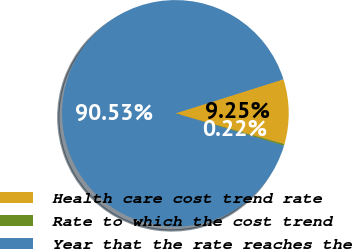<chart> <loc_0><loc_0><loc_500><loc_500><pie_chart><fcel>Health care cost trend rate<fcel>Rate to which the cost trend<fcel>Year that the rate reaches the<nl><fcel>9.25%<fcel>0.22%<fcel>90.52%<nl></chart> 